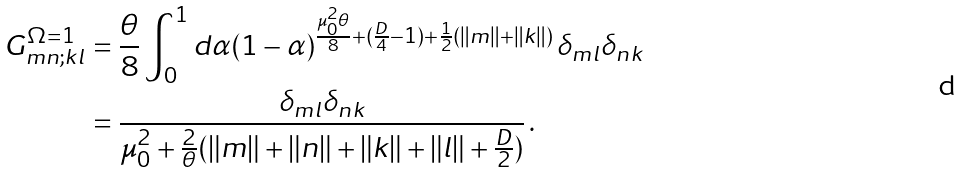<formula> <loc_0><loc_0><loc_500><loc_500>G ^ { \Omega = 1 } _ { m n ; k l } & = \frac { \theta } { 8 } \int _ { 0 } ^ { 1 } d \alpha ( 1 - \alpha ) ^ { \frac { \mu _ { 0 } ^ { 2 } \theta } { 8 } + ( \frac { D } { 4 } - 1 ) + \frac { 1 } { 2 } ( \| m \| + \| k \| ) } \, \delta _ { m l } \delta _ { n k } \\ & = \frac { \delta _ { m l } \delta _ { n k } } { \mu _ { 0 } ^ { 2 } + \frac { 2 } { \theta } ( \| m \| + \| n \| + \| k \| + \| l \| + \frac { D } { 2 } ) } \, .</formula> 